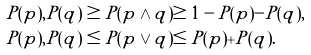Convert formula to latex. <formula><loc_0><loc_0><loc_500><loc_500>P ( p ) , P ( q ) & \geq P ( p \land q ) \geq 1 - P ( p ) - P ( q ) , \\ P ( p ) , P ( q ) & \leq P ( p \lor q ) \leq P ( p ) + P ( q ) .</formula> 